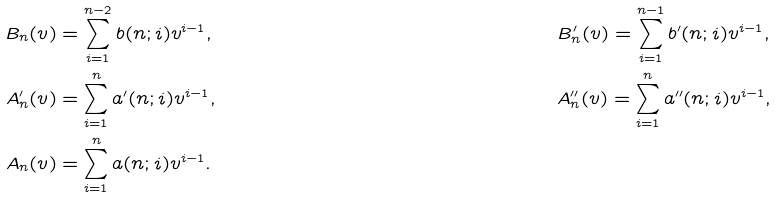<formula> <loc_0><loc_0><loc_500><loc_500>B _ { n } ( v ) & = \sum _ { i = 1 } ^ { n - 2 } b ( n ; i ) v ^ { i - 1 } , & & B ^ { \prime } _ { n } ( v ) = \sum _ { i = 1 } ^ { n - 1 } b ^ { \prime } ( n ; i ) v ^ { i - 1 } , \\ A ^ { \prime } _ { n } ( v ) & = \sum _ { i = 1 } ^ { n } a ^ { \prime } ( n ; i ) v ^ { i - 1 } , & & A ^ { \prime \prime } _ { n } ( v ) = \sum _ { i = 1 } ^ { n } a ^ { \prime \prime } ( n ; i ) v ^ { i - 1 } , \\ A _ { n } ( v ) & = \sum _ { i = 1 } ^ { n } a ( n ; i ) v ^ { i - 1 } .</formula> 